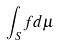Convert formula to latex. <formula><loc_0><loc_0><loc_500><loc_500>\int _ { S } f d \mu</formula> 